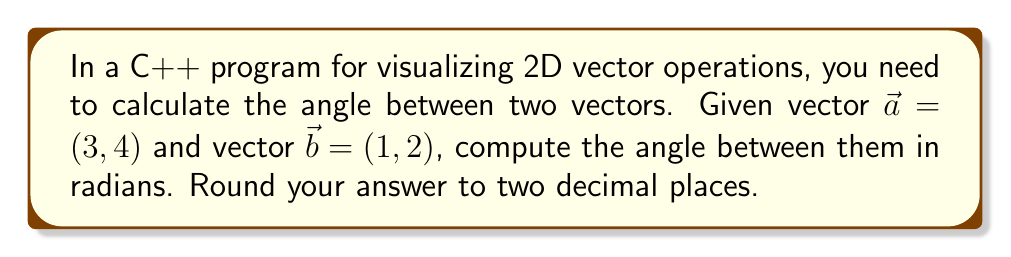Give your solution to this math problem. To find the angle between two vectors in a 2D plane, we can use the dot product formula:

$$\cos \theta = \frac{\vec{a} \cdot \vec{b}}{|\vec{a}| |\vec{b}|}$$

Where $\theta$ is the angle between the vectors, $\vec{a} \cdot \vec{b}$ is the dot product, and $|\vec{a}|$ and $|\vec{b}|$ are the magnitudes of the vectors.

Step 1: Calculate the dot product
$$\vec{a} \cdot \vec{b} = (3 \times 1) + (4 \times 2) = 3 + 8 = 11$$

Step 2: Calculate the magnitudes
$$|\vec{a}| = \sqrt{3^2 + 4^2} = \sqrt{9 + 16} = \sqrt{25} = 5$$
$$|\vec{b}| = \sqrt{1^2 + 2^2} = \sqrt{1 + 4} = \sqrt{5}$$

Step 3: Apply the formula
$$\cos \theta = \frac{11}{5\sqrt{5}}$$

Step 4: Take the inverse cosine (arccos) of both sides
$$\theta = \arccos\left(\frac{11}{5\sqrt{5}}\right)$$

Step 5: Calculate the result and round to two decimal places
$$\theta \approx 0.25 \text{ radians}$$
Answer: 0.25 radians 